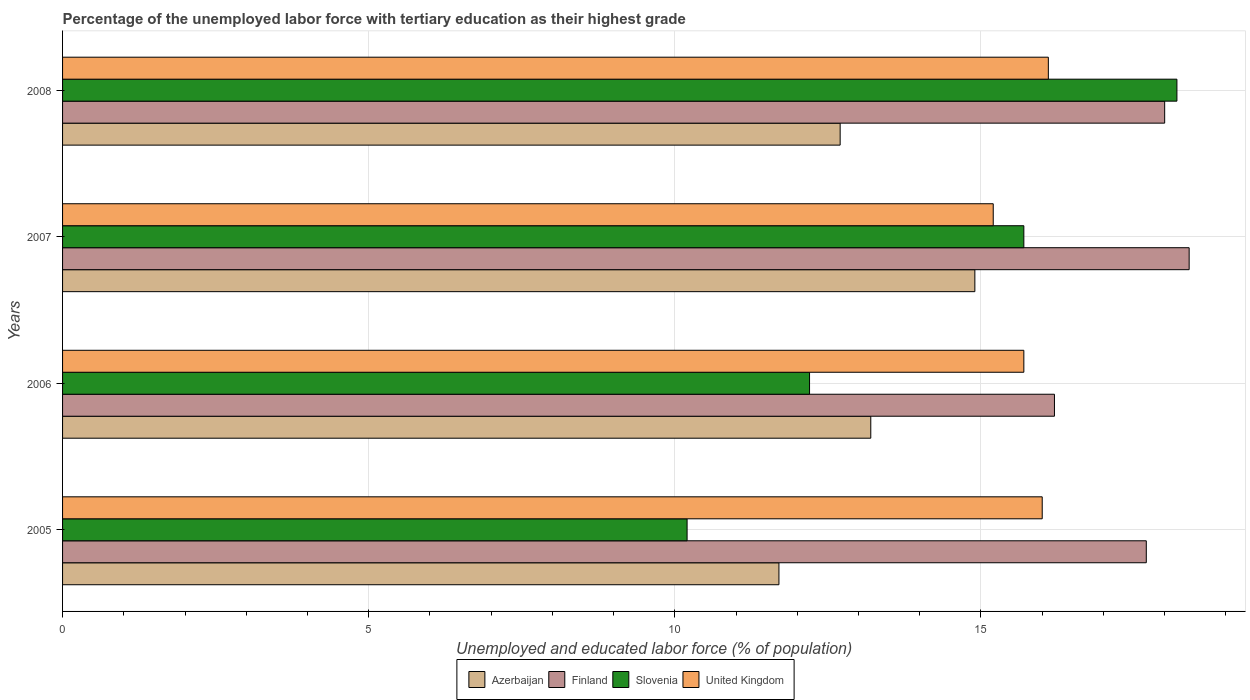How many groups of bars are there?
Your answer should be very brief. 4. Are the number of bars per tick equal to the number of legend labels?
Offer a terse response. Yes. How many bars are there on the 4th tick from the bottom?
Keep it short and to the point. 4. What is the percentage of the unemployed labor force with tertiary education in Azerbaijan in 2005?
Your response must be concise. 11.7. Across all years, what is the maximum percentage of the unemployed labor force with tertiary education in Finland?
Your answer should be very brief. 18.4. Across all years, what is the minimum percentage of the unemployed labor force with tertiary education in United Kingdom?
Keep it short and to the point. 15.2. In which year was the percentage of the unemployed labor force with tertiary education in United Kingdom maximum?
Your response must be concise. 2008. In which year was the percentage of the unemployed labor force with tertiary education in Azerbaijan minimum?
Offer a very short reply. 2005. What is the total percentage of the unemployed labor force with tertiary education in Azerbaijan in the graph?
Your answer should be compact. 52.5. What is the difference between the percentage of the unemployed labor force with tertiary education in Finland in 2005 and that in 2007?
Keep it short and to the point. -0.7. What is the difference between the percentage of the unemployed labor force with tertiary education in Finland in 2006 and the percentage of the unemployed labor force with tertiary education in United Kingdom in 2008?
Your answer should be compact. 0.1. What is the average percentage of the unemployed labor force with tertiary education in Azerbaijan per year?
Ensure brevity in your answer.  13.12. In the year 2008, what is the difference between the percentage of the unemployed labor force with tertiary education in Finland and percentage of the unemployed labor force with tertiary education in Slovenia?
Offer a very short reply. -0.2. What is the ratio of the percentage of the unemployed labor force with tertiary education in Azerbaijan in 2005 to that in 2008?
Your response must be concise. 0.92. Is the percentage of the unemployed labor force with tertiary education in Azerbaijan in 2005 less than that in 2008?
Your response must be concise. Yes. Is the difference between the percentage of the unemployed labor force with tertiary education in Finland in 2007 and 2008 greater than the difference between the percentage of the unemployed labor force with tertiary education in Slovenia in 2007 and 2008?
Provide a short and direct response. Yes. What is the difference between the highest and the second highest percentage of the unemployed labor force with tertiary education in Slovenia?
Provide a short and direct response. 2.5. What is the difference between the highest and the lowest percentage of the unemployed labor force with tertiary education in Azerbaijan?
Offer a very short reply. 3.2. In how many years, is the percentage of the unemployed labor force with tertiary education in Finland greater than the average percentage of the unemployed labor force with tertiary education in Finland taken over all years?
Your answer should be very brief. 3. Is the sum of the percentage of the unemployed labor force with tertiary education in United Kingdom in 2006 and 2007 greater than the maximum percentage of the unemployed labor force with tertiary education in Azerbaijan across all years?
Keep it short and to the point. Yes. What does the 2nd bar from the top in 2007 represents?
Your answer should be very brief. Slovenia. What does the 3rd bar from the bottom in 2008 represents?
Provide a short and direct response. Slovenia. What is the difference between two consecutive major ticks on the X-axis?
Provide a succinct answer. 5. Are the values on the major ticks of X-axis written in scientific E-notation?
Provide a succinct answer. No. Where does the legend appear in the graph?
Make the answer very short. Bottom center. How are the legend labels stacked?
Offer a very short reply. Horizontal. What is the title of the graph?
Offer a terse response. Percentage of the unemployed labor force with tertiary education as their highest grade. What is the label or title of the X-axis?
Keep it short and to the point. Unemployed and educated labor force (% of population). What is the label or title of the Y-axis?
Ensure brevity in your answer.  Years. What is the Unemployed and educated labor force (% of population) of Azerbaijan in 2005?
Offer a terse response. 11.7. What is the Unemployed and educated labor force (% of population) of Finland in 2005?
Offer a very short reply. 17.7. What is the Unemployed and educated labor force (% of population) of Slovenia in 2005?
Make the answer very short. 10.2. What is the Unemployed and educated labor force (% of population) of Azerbaijan in 2006?
Your answer should be compact. 13.2. What is the Unemployed and educated labor force (% of population) in Finland in 2006?
Offer a terse response. 16.2. What is the Unemployed and educated labor force (% of population) in Slovenia in 2006?
Your response must be concise. 12.2. What is the Unemployed and educated labor force (% of population) of United Kingdom in 2006?
Keep it short and to the point. 15.7. What is the Unemployed and educated labor force (% of population) of Azerbaijan in 2007?
Provide a short and direct response. 14.9. What is the Unemployed and educated labor force (% of population) in Finland in 2007?
Offer a terse response. 18.4. What is the Unemployed and educated labor force (% of population) of Slovenia in 2007?
Offer a very short reply. 15.7. What is the Unemployed and educated labor force (% of population) in United Kingdom in 2007?
Your answer should be compact. 15.2. What is the Unemployed and educated labor force (% of population) of Azerbaijan in 2008?
Make the answer very short. 12.7. What is the Unemployed and educated labor force (% of population) in Finland in 2008?
Offer a very short reply. 18. What is the Unemployed and educated labor force (% of population) of Slovenia in 2008?
Offer a very short reply. 18.2. What is the Unemployed and educated labor force (% of population) in United Kingdom in 2008?
Your answer should be compact. 16.1. Across all years, what is the maximum Unemployed and educated labor force (% of population) of Azerbaijan?
Your answer should be very brief. 14.9. Across all years, what is the maximum Unemployed and educated labor force (% of population) in Finland?
Provide a short and direct response. 18.4. Across all years, what is the maximum Unemployed and educated labor force (% of population) of Slovenia?
Your response must be concise. 18.2. Across all years, what is the maximum Unemployed and educated labor force (% of population) of United Kingdom?
Offer a very short reply. 16.1. Across all years, what is the minimum Unemployed and educated labor force (% of population) in Azerbaijan?
Your response must be concise. 11.7. Across all years, what is the minimum Unemployed and educated labor force (% of population) of Finland?
Make the answer very short. 16.2. Across all years, what is the minimum Unemployed and educated labor force (% of population) of Slovenia?
Provide a short and direct response. 10.2. Across all years, what is the minimum Unemployed and educated labor force (% of population) in United Kingdom?
Make the answer very short. 15.2. What is the total Unemployed and educated labor force (% of population) of Azerbaijan in the graph?
Make the answer very short. 52.5. What is the total Unemployed and educated labor force (% of population) in Finland in the graph?
Provide a short and direct response. 70.3. What is the total Unemployed and educated labor force (% of population) of Slovenia in the graph?
Your response must be concise. 56.3. What is the difference between the Unemployed and educated labor force (% of population) of Finland in 2005 and that in 2007?
Your response must be concise. -0.7. What is the difference between the Unemployed and educated labor force (% of population) of Slovenia in 2005 and that in 2007?
Keep it short and to the point. -5.5. What is the difference between the Unemployed and educated labor force (% of population) in Azerbaijan in 2005 and that in 2008?
Your answer should be very brief. -1. What is the difference between the Unemployed and educated labor force (% of population) in Azerbaijan in 2006 and that in 2007?
Ensure brevity in your answer.  -1.7. What is the difference between the Unemployed and educated labor force (% of population) in Slovenia in 2006 and that in 2007?
Keep it short and to the point. -3.5. What is the difference between the Unemployed and educated labor force (% of population) in Finland in 2006 and that in 2008?
Keep it short and to the point. -1.8. What is the difference between the Unemployed and educated labor force (% of population) in United Kingdom in 2006 and that in 2008?
Your response must be concise. -0.4. What is the difference between the Unemployed and educated labor force (% of population) of Azerbaijan in 2007 and that in 2008?
Ensure brevity in your answer.  2.2. What is the difference between the Unemployed and educated labor force (% of population) in Slovenia in 2007 and that in 2008?
Your answer should be very brief. -2.5. What is the difference between the Unemployed and educated labor force (% of population) of Azerbaijan in 2005 and the Unemployed and educated labor force (% of population) of Finland in 2006?
Offer a very short reply. -4.5. What is the difference between the Unemployed and educated labor force (% of population) of Azerbaijan in 2005 and the Unemployed and educated labor force (% of population) of Slovenia in 2006?
Provide a succinct answer. -0.5. What is the difference between the Unemployed and educated labor force (% of population) in Finland in 2005 and the Unemployed and educated labor force (% of population) in Slovenia in 2006?
Provide a succinct answer. 5.5. What is the difference between the Unemployed and educated labor force (% of population) in Finland in 2005 and the Unemployed and educated labor force (% of population) in United Kingdom in 2006?
Your answer should be very brief. 2. What is the difference between the Unemployed and educated labor force (% of population) in Azerbaijan in 2005 and the Unemployed and educated labor force (% of population) in Slovenia in 2007?
Offer a very short reply. -4. What is the difference between the Unemployed and educated labor force (% of population) in Azerbaijan in 2005 and the Unemployed and educated labor force (% of population) in United Kingdom in 2007?
Make the answer very short. -3.5. What is the difference between the Unemployed and educated labor force (% of population) in Azerbaijan in 2005 and the Unemployed and educated labor force (% of population) in Finland in 2008?
Your answer should be compact. -6.3. What is the difference between the Unemployed and educated labor force (% of population) of Finland in 2005 and the Unemployed and educated labor force (% of population) of Slovenia in 2008?
Ensure brevity in your answer.  -0.5. What is the difference between the Unemployed and educated labor force (% of population) of Azerbaijan in 2006 and the Unemployed and educated labor force (% of population) of Finland in 2007?
Your answer should be very brief. -5.2. What is the difference between the Unemployed and educated labor force (% of population) of Azerbaijan in 2006 and the Unemployed and educated labor force (% of population) of Slovenia in 2007?
Keep it short and to the point. -2.5. What is the difference between the Unemployed and educated labor force (% of population) in Finland in 2006 and the Unemployed and educated labor force (% of population) in Slovenia in 2007?
Your answer should be compact. 0.5. What is the difference between the Unemployed and educated labor force (% of population) of Finland in 2006 and the Unemployed and educated labor force (% of population) of United Kingdom in 2007?
Keep it short and to the point. 1. What is the difference between the Unemployed and educated labor force (% of population) of Slovenia in 2006 and the Unemployed and educated labor force (% of population) of United Kingdom in 2007?
Give a very brief answer. -3. What is the difference between the Unemployed and educated labor force (% of population) in Azerbaijan in 2006 and the Unemployed and educated labor force (% of population) in Slovenia in 2008?
Your answer should be very brief. -5. What is the difference between the Unemployed and educated labor force (% of population) in Finland in 2006 and the Unemployed and educated labor force (% of population) in Slovenia in 2008?
Make the answer very short. -2. What is the difference between the Unemployed and educated labor force (% of population) of Finland in 2006 and the Unemployed and educated labor force (% of population) of United Kingdom in 2008?
Your answer should be compact. 0.1. What is the difference between the Unemployed and educated labor force (% of population) of Azerbaijan in 2007 and the Unemployed and educated labor force (% of population) of United Kingdom in 2008?
Make the answer very short. -1.2. What is the difference between the Unemployed and educated labor force (% of population) of Slovenia in 2007 and the Unemployed and educated labor force (% of population) of United Kingdom in 2008?
Your answer should be compact. -0.4. What is the average Unemployed and educated labor force (% of population) of Azerbaijan per year?
Your response must be concise. 13.12. What is the average Unemployed and educated labor force (% of population) in Finland per year?
Your answer should be very brief. 17.57. What is the average Unemployed and educated labor force (% of population) of Slovenia per year?
Ensure brevity in your answer.  14.07. What is the average Unemployed and educated labor force (% of population) in United Kingdom per year?
Your answer should be compact. 15.75. In the year 2005, what is the difference between the Unemployed and educated labor force (% of population) in Azerbaijan and Unemployed and educated labor force (% of population) in Finland?
Ensure brevity in your answer.  -6. In the year 2005, what is the difference between the Unemployed and educated labor force (% of population) of Azerbaijan and Unemployed and educated labor force (% of population) of Slovenia?
Offer a very short reply. 1.5. In the year 2005, what is the difference between the Unemployed and educated labor force (% of population) in Azerbaijan and Unemployed and educated labor force (% of population) in United Kingdom?
Provide a succinct answer. -4.3. In the year 2005, what is the difference between the Unemployed and educated labor force (% of population) in Finland and Unemployed and educated labor force (% of population) in United Kingdom?
Offer a terse response. 1.7. In the year 2005, what is the difference between the Unemployed and educated labor force (% of population) in Slovenia and Unemployed and educated labor force (% of population) in United Kingdom?
Give a very brief answer. -5.8. In the year 2006, what is the difference between the Unemployed and educated labor force (% of population) in Azerbaijan and Unemployed and educated labor force (% of population) in Finland?
Offer a very short reply. -3. In the year 2006, what is the difference between the Unemployed and educated labor force (% of population) of Azerbaijan and Unemployed and educated labor force (% of population) of Slovenia?
Provide a short and direct response. 1. In the year 2006, what is the difference between the Unemployed and educated labor force (% of population) in Azerbaijan and Unemployed and educated labor force (% of population) in United Kingdom?
Keep it short and to the point. -2.5. In the year 2007, what is the difference between the Unemployed and educated labor force (% of population) in Azerbaijan and Unemployed and educated labor force (% of population) in Slovenia?
Your answer should be compact. -0.8. In the year 2007, what is the difference between the Unemployed and educated labor force (% of population) of Slovenia and Unemployed and educated labor force (% of population) of United Kingdom?
Give a very brief answer. 0.5. In the year 2008, what is the difference between the Unemployed and educated labor force (% of population) in Azerbaijan and Unemployed and educated labor force (% of population) in Finland?
Keep it short and to the point. -5.3. In the year 2008, what is the difference between the Unemployed and educated labor force (% of population) in Azerbaijan and Unemployed and educated labor force (% of population) in United Kingdom?
Offer a terse response. -3.4. In the year 2008, what is the difference between the Unemployed and educated labor force (% of population) in Finland and Unemployed and educated labor force (% of population) in Slovenia?
Keep it short and to the point. -0.2. In the year 2008, what is the difference between the Unemployed and educated labor force (% of population) in Finland and Unemployed and educated labor force (% of population) in United Kingdom?
Your answer should be very brief. 1.9. What is the ratio of the Unemployed and educated labor force (% of population) of Azerbaijan in 2005 to that in 2006?
Make the answer very short. 0.89. What is the ratio of the Unemployed and educated labor force (% of population) of Finland in 2005 to that in 2006?
Your answer should be compact. 1.09. What is the ratio of the Unemployed and educated labor force (% of population) in Slovenia in 2005 to that in 2006?
Ensure brevity in your answer.  0.84. What is the ratio of the Unemployed and educated labor force (% of population) in United Kingdom in 2005 to that in 2006?
Ensure brevity in your answer.  1.02. What is the ratio of the Unemployed and educated labor force (% of population) of Azerbaijan in 2005 to that in 2007?
Your answer should be compact. 0.79. What is the ratio of the Unemployed and educated labor force (% of population) of Finland in 2005 to that in 2007?
Make the answer very short. 0.96. What is the ratio of the Unemployed and educated labor force (% of population) of Slovenia in 2005 to that in 2007?
Make the answer very short. 0.65. What is the ratio of the Unemployed and educated labor force (% of population) of United Kingdom in 2005 to that in 2007?
Offer a very short reply. 1.05. What is the ratio of the Unemployed and educated labor force (% of population) of Azerbaijan in 2005 to that in 2008?
Give a very brief answer. 0.92. What is the ratio of the Unemployed and educated labor force (% of population) of Finland in 2005 to that in 2008?
Your answer should be compact. 0.98. What is the ratio of the Unemployed and educated labor force (% of population) of Slovenia in 2005 to that in 2008?
Keep it short and to the point. 0.56. What is the ratio of the Unemployed and educated labor force (% of population) of Azerbaijan in 2006 to that in 2007?
Ensure brevity in your answer.  0.89. What is the ratio of the Unemployed and educated labor force (% of population) in Finland in 2006 to that in 2007?
Give a very brief answer. 0.88. What is the ratio of the Unemployed and educated labor force (% of population) in Slovenia in 2006 to that in 2007?
Ensure brevity in your answer.  0.78. What is the ratio of the Unemployed and educated labor force (% of population) of United Kingdom in 2006 to that in 2007?
Provide a short and direct response. 1.03. What is the ratio of the Unemployed and educated labor force (% of population) of Azerbaijan in 2006 to that in 2008?
Provide a short and direct response. 1.04. What is the ratio of the Unemployed and educated labor force (% of population) of Finland in 2006 to that in 2008?
Offer a terse response. 0.9. What is the ratio of the Unemployed and educated labor force (% of population) of Slovenia in 2006 to that in 2008?
Make the answer very short. 0.67. What is the ratio of the Unemployed and educated labor force (% of population) of United Kingdom in 2006 to that in 2008?
Ensure brevity in your answer.  0.98. What is the ratio of the Unemployed and educated labor force (% of population) of Azerbaijan in 2007 to that in 2008?
Ensure brevity in your answer.  1.17. What is the ratio of the Unemployed and educated labor force (% of population) of Finland in 2007 to that in 2008?
Keep it short and to the point. 1.02. What is the ratio of the Unemployed and educated labor force (% of population) in Slovenia in 2007 to that in 2008?
Keep it short and to the point. 0.86. What is the ratio of the Unemployed and educated labor force (% of population) of United Kingdom in 2007 to that in 2008?
Your answer should be compact. 0.94. What is the difference between the highest and the lowest Unemployed and educated labor force (% of population) in Azerbaijan?
Give a very brief answer. 3.2. What is the difference between the highest and the lowest Unemployed and educated labor force (% of population) in Finland?
Your answer should be very brief. 2.2. What is the difference between the highest and the lowest Unemployed and educated labor force (% of population) of United Kingdom?
Offer a terse response. 0.9. 